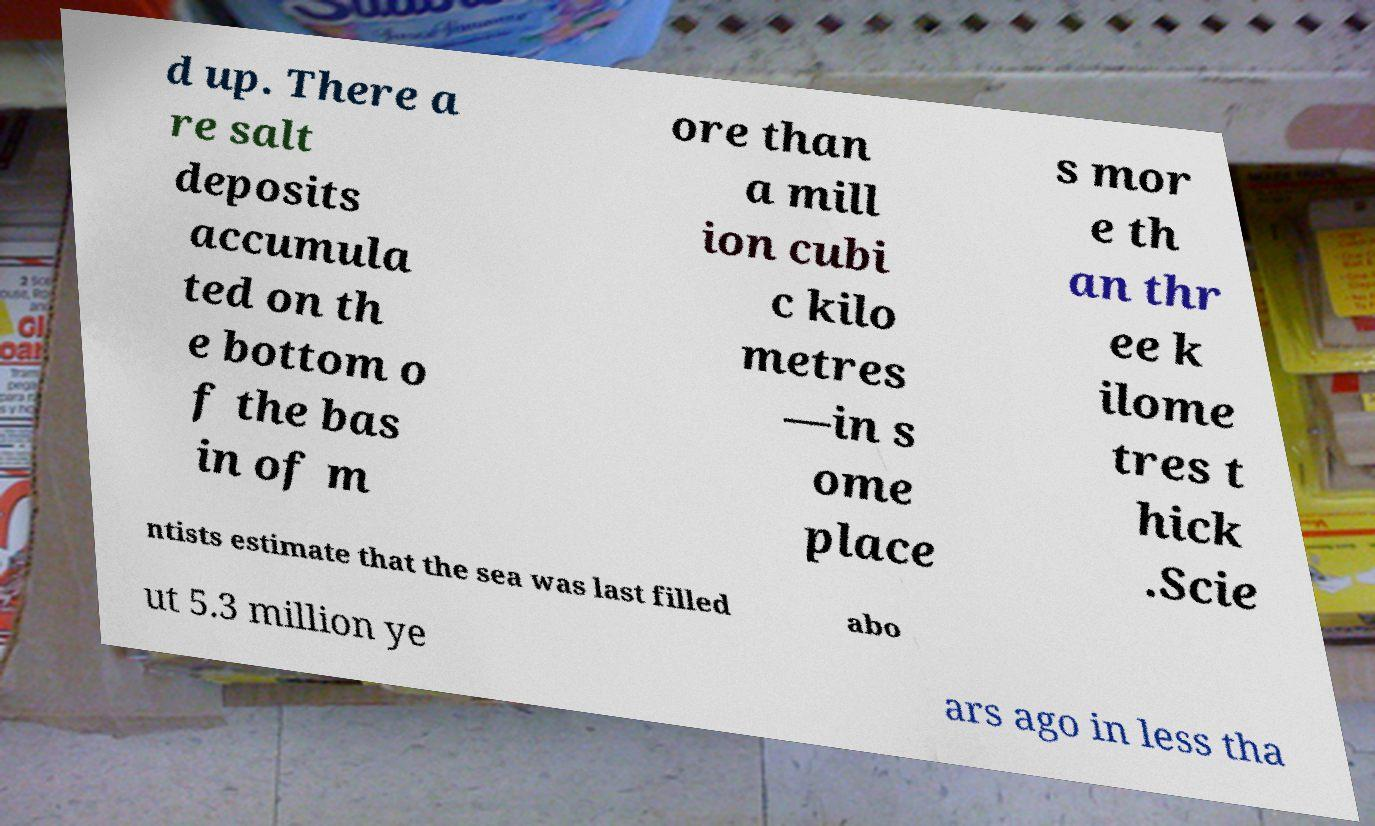Please identify and transcribe the text found in this image. d up. There a re salt deposits accumula ted on th e bottom o f the bas in of m ore than a mill ion cubi c kilo metres —in s ome place s mor e th an thr ee k ilome tres t hick .Scie ntists estimate that the sea was last filled abo ut 5.3 million ye ars ago in less tha 